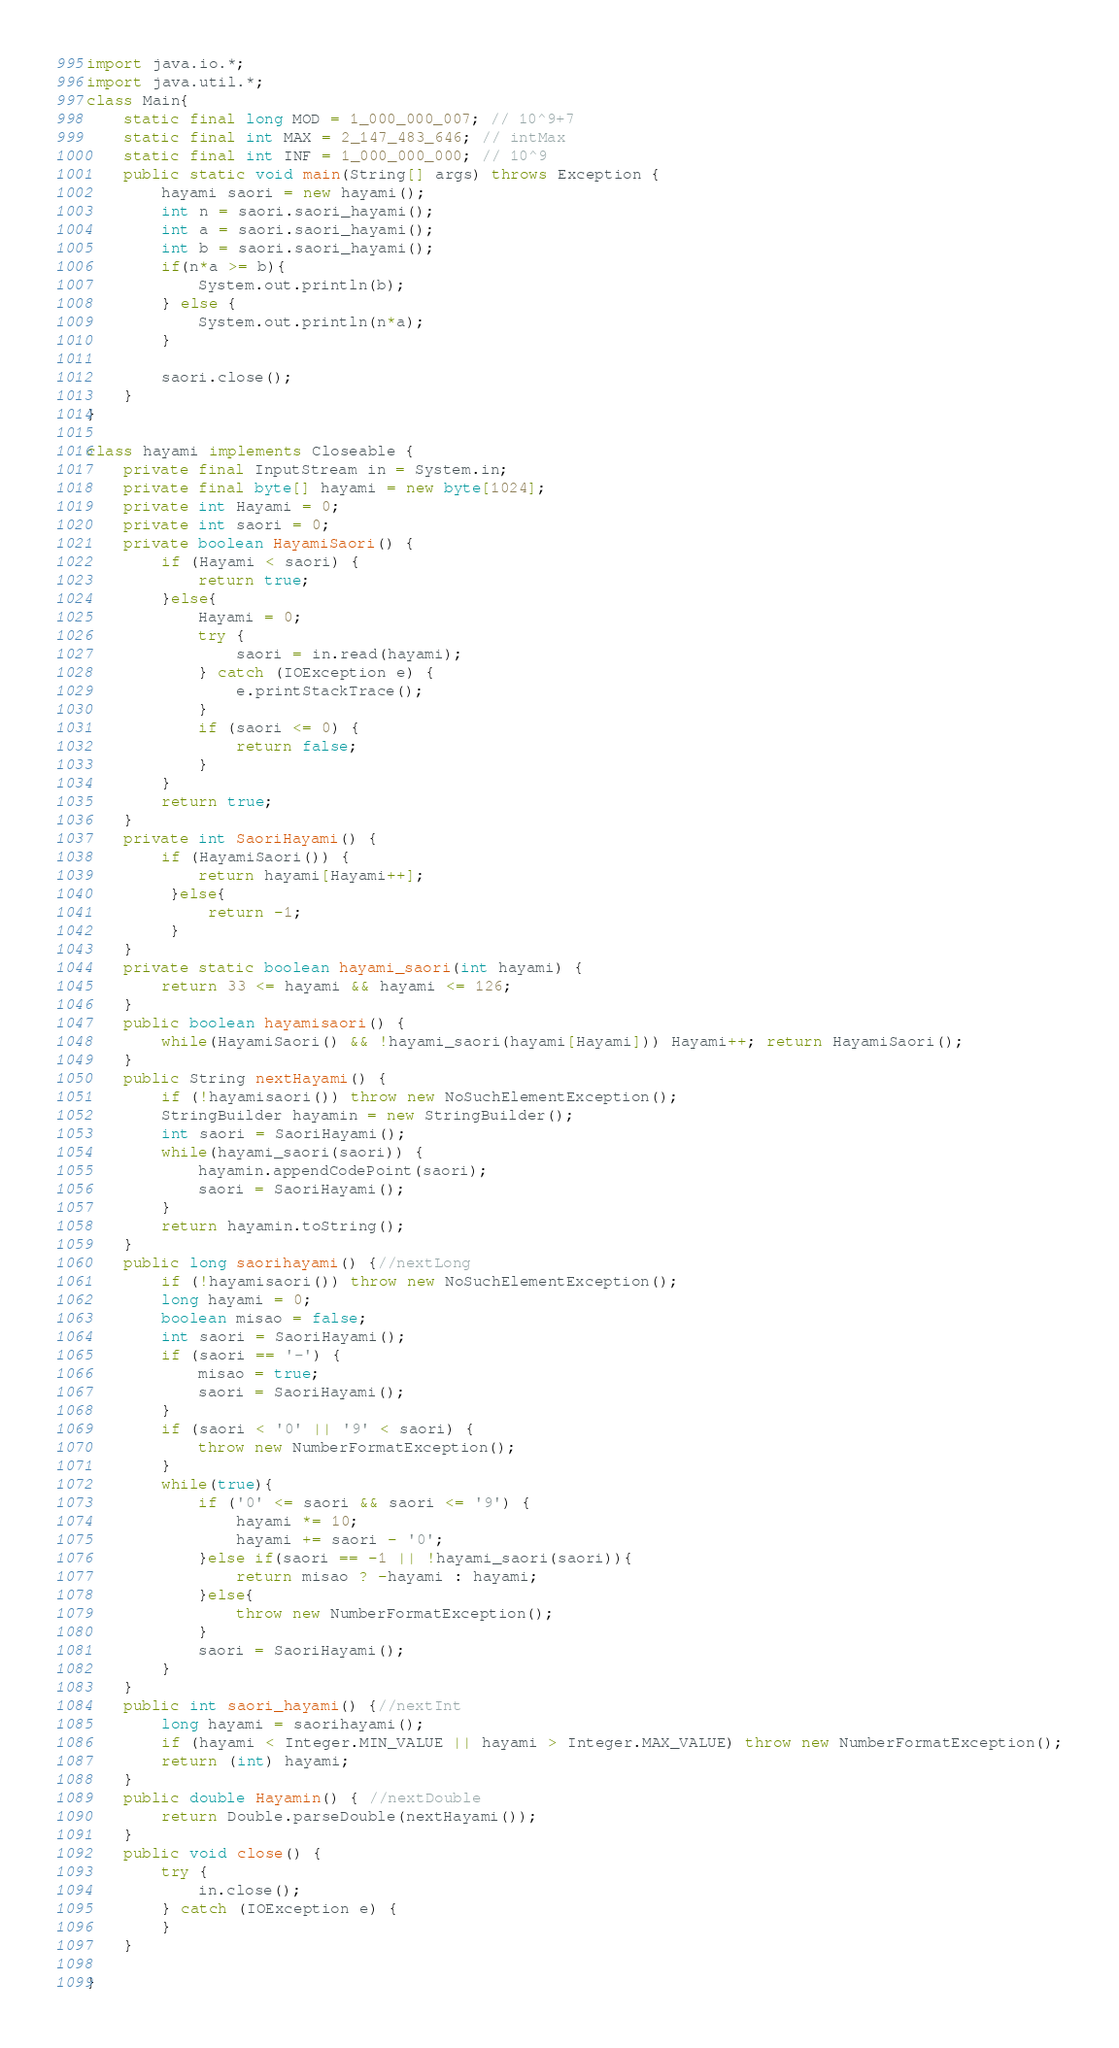<code> <loc_0><loc_0><loc_500><loc_500><_Java_>import java.io.*;
import java.util.*;
class Main{
	static final long MOD = 1_000_000_007; // 10^9+7
    static final int MAX = 2_147_483_646; // intMax 
    static final int INF = 1_000_000_000; // 10^9  
    public static void main(String[] args) throws Exception {
		hayami saori = new hayami();
		int n = saori.saori_hayami();
		int a = saori.saori_hayami();
		int b = saori.saori_hayami();
		if(n*a >= b){
			System.out.println(b);
		} else {
			System.out.println(n*a);
		}
		
		saori.close();
    }
}

class hayami implements Closeable {
	private final InputStream in = System.in;
	private final byte[] hayami = new byte[1024];
	private int Hayami = 0;
	private int saori = 0;
	private boolean HayamiSaori() {
		if (Hayami < saori) {
			return true;
		}else{
			Hayami = 0;
			try {
				saori = in.read(hayami);
			} catch (IOException e) {
				e.printStackTrace();
			}
			if (saori <= 0) {
				return false;
			}
		}
		return true;
	}
	private int SaoriHayami() { 
		if (HayamiSaori()) {
            return hayami[Hayami++];
         }else{
             return -1;
         }
	}
	private static boolean hayami_saori(int hayami) { 
		return 33 <= hayami && hayami <= 126;
	}
	public boolean hayamisaori() { 
		while(HayamiSaori() && !hayami_saori(hayami[Hayami])) Hayami++; return HayamiSaori();
	}
	public String nextHayami() {
		if (!hayamisaori()) throw new NoSuchElementException();
		StringBuilder hayamin = new StringBuilder();
		int saori = SaoriHayami();
		while(hayami_saori(saori)) {
			hayamin.appendCodePoint(saori);
			saori = SaoriHayami();
		}
		return hayamin.toString();
	}
	public long saorihayami() {//nextLong
		if (!hayamisaori()) throw new NoSuchElementException();
		long hayami = 0;
		boolean misao = false;
		int saori = SaoriHayami();
		if (saori == '-') {
			misao = true;
			saori = SaoriHayami();
		}
		if (saori < '0' || '9' < saori) {
			throw new NumberFormatException();
		}
		while(true){
			if ('0' <= saori && saori <= '9') {
				hayami *= 10;
				hayami += saori - '0';
			}else if(saori == -1 || !hayami_saori(saori)){
				return misao ? -hayami : hayami;
			}else{
				throw new NumberFormatException();
			}
			saori = SaoriHayami();
		}
	}
	public int saori_hayami() {//nextInt
		long hayami = saorihayami();
		if (hayami < Integer.MIN_VALUE || hayami > Integer.MAX_VALUE) throw new NumberFormatException();
		return (int) hayami;
	}
	public double Hayamin() { //nextDouble
		return Double.parseDouble(nextHayami());
	}
	public void close() {
		try {
			in.close();
		} catch (IOException e) {
		}
    }
    
}</code> 